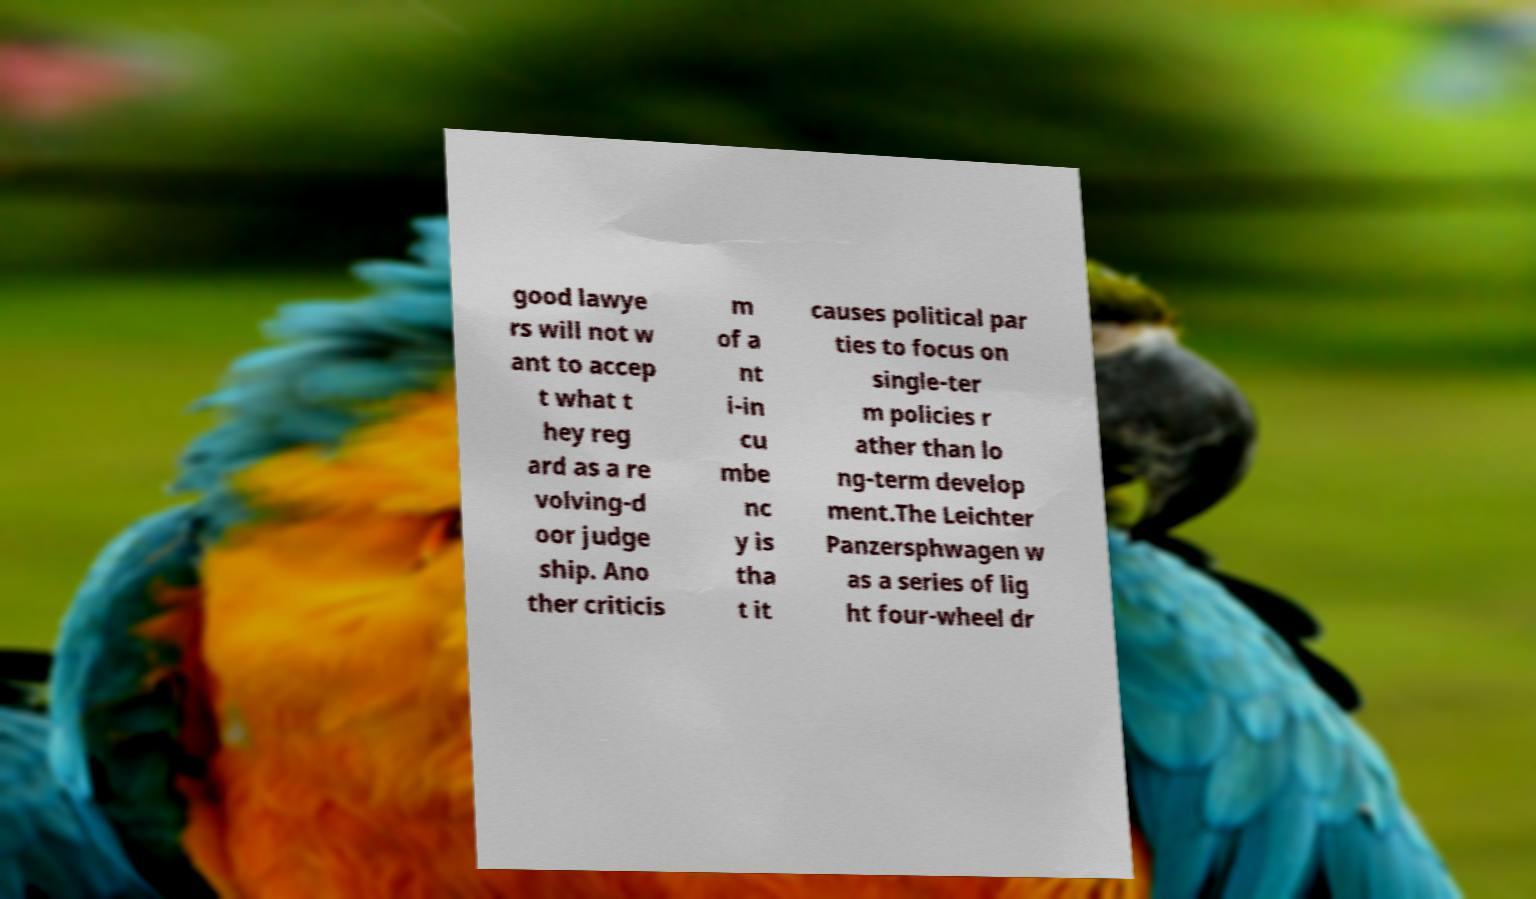Please identify and transcribe the text found in this image. good lawye rs will not w ant to accep t what t hey reg ard as a re volving-d oor judge ship. Ano ther criticis m of a nt i-in cu mbe nc y is tha t it causes political par ties to focus on single-ter m policies r ather than lo ng-term develop ment.The Leichter Panzersphwagen w as a series of lig ht four-wheel dr 